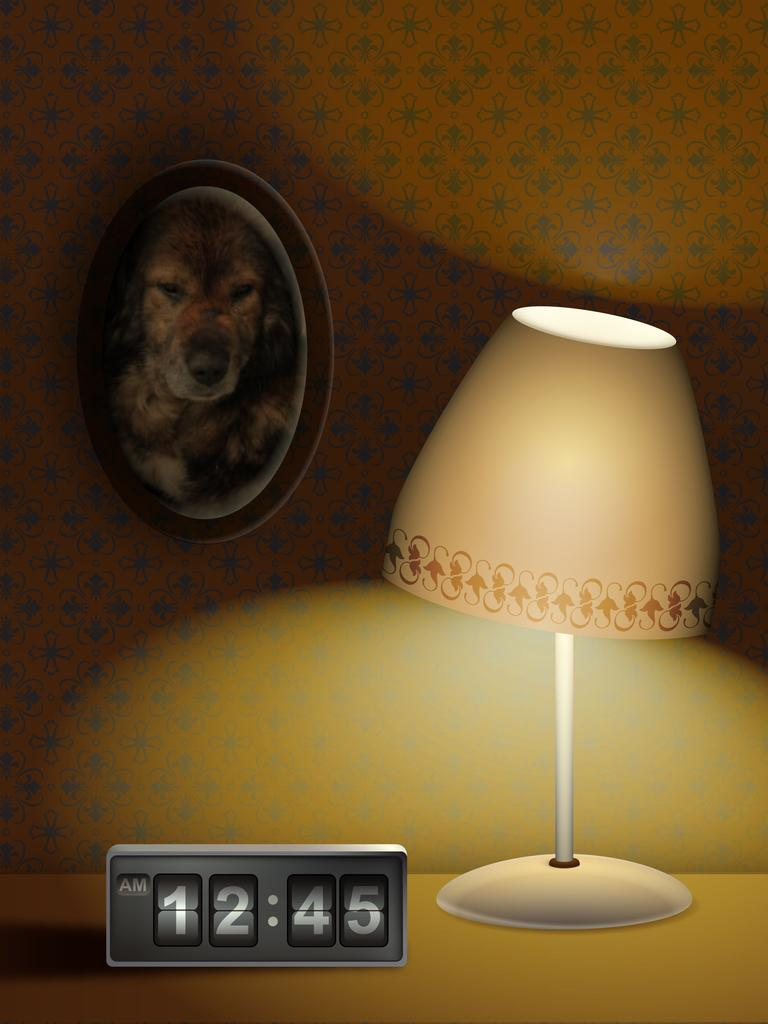What type of lighting device is present in the image? There is a lamp in the image. What time-keeping device is visible in the image? There is a digital clock in the image. Where are the lamp and digital clock located? The lamp and digital clock are on a table in the image. What is another object present in the image related to displaying images? There is a photo frame in the image. Where is the photo frame positioned in the image? The photo frame is attached to a wall in the image. What type of fuel is being used by the society depicted in the image? There is no society depicted in the image, and therefore no fuel usage can be observed. 